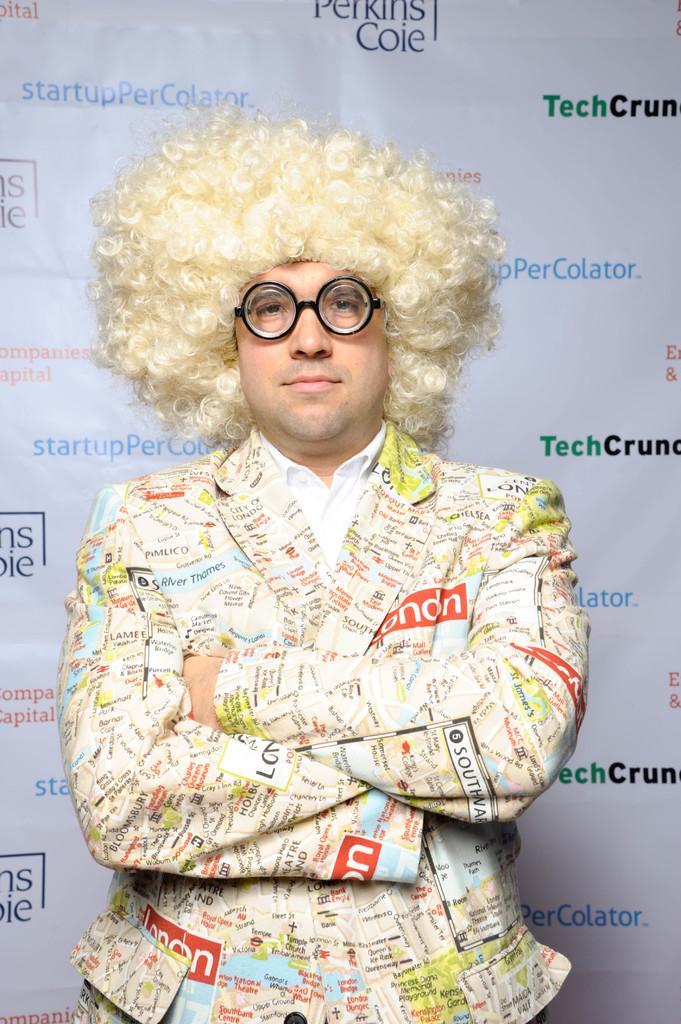Can you describe this image briefly? In the middle of the image, there is a person in a shirt, wearing a spectacle, smiling and standing. In the background, there are different color texts on a white color banner. 